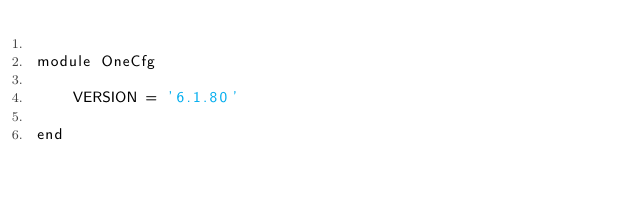<code> <loc_0><loc_0><loc_500><loc_500><_Ruby_>
module OneCfg

    VERSION = '6.1.80'

end
</code> 